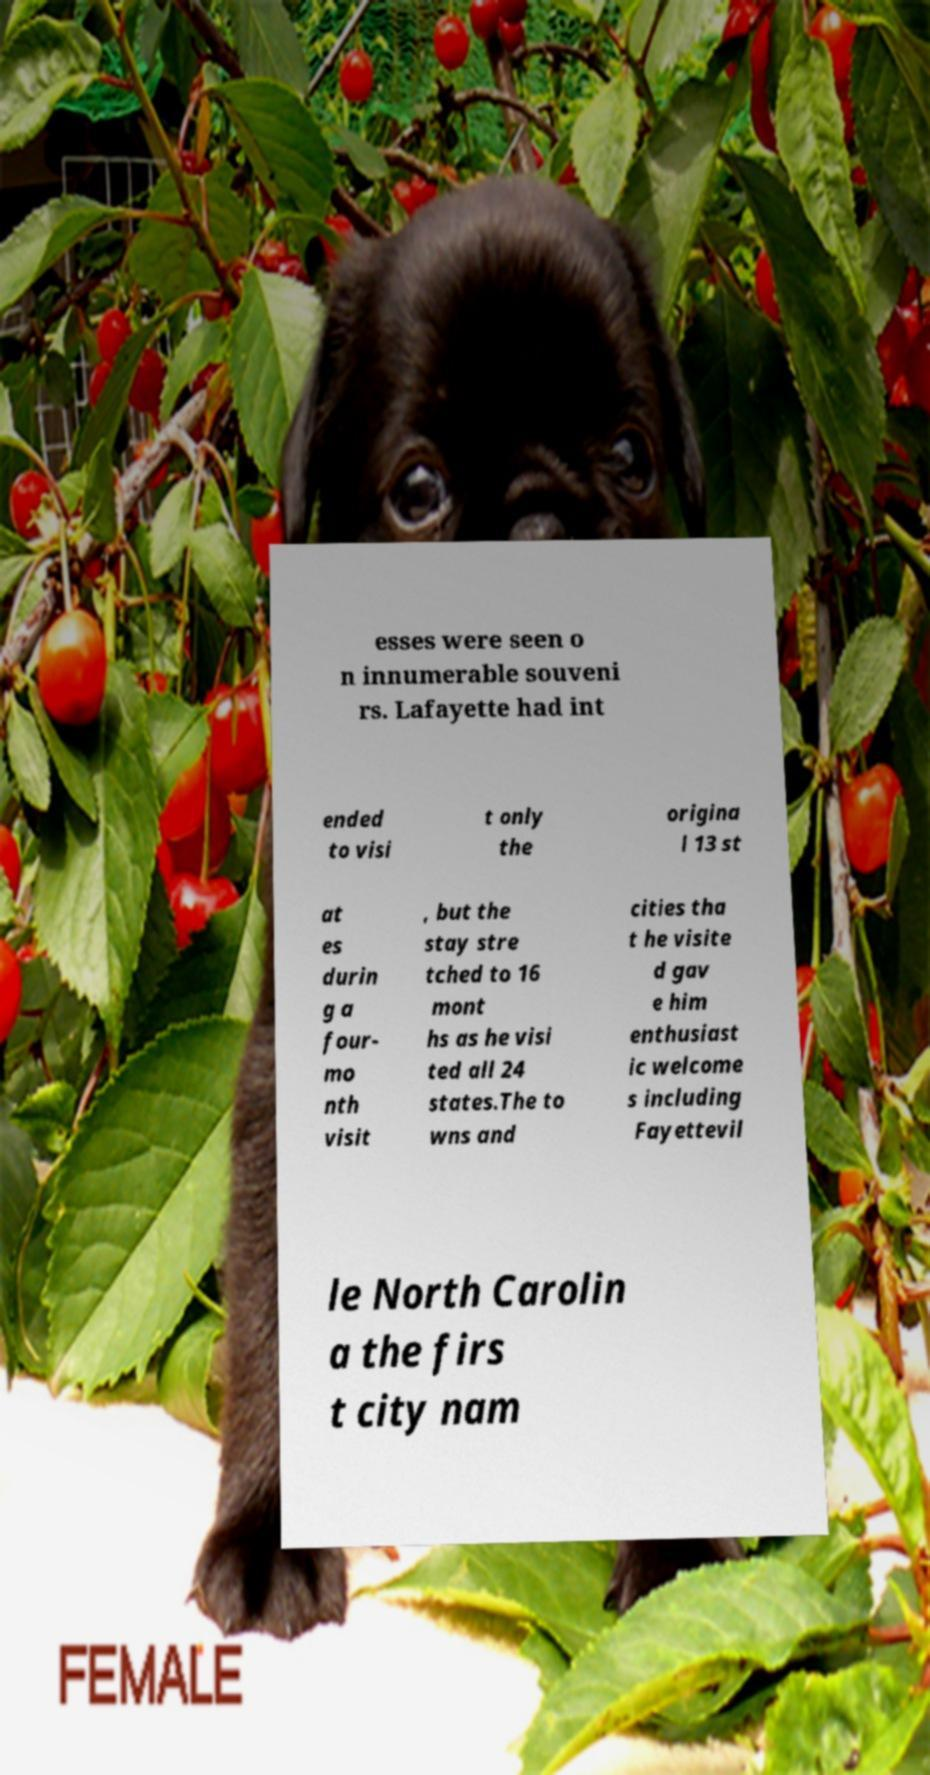Please identify and transcribe the text found in this image. esses were seen o n innumerable souveni rs. Lafayette had int ended to visi t only the origina l 13 st at es durin g a four- mo nth visit , but the stay stre tched to 16 mont hs as he visi ted all 24 states.The to wns and cities tha t he visite d gav e him enthusiast ic welcome s including Fayettevil le North Carolin a the firs t city nam 